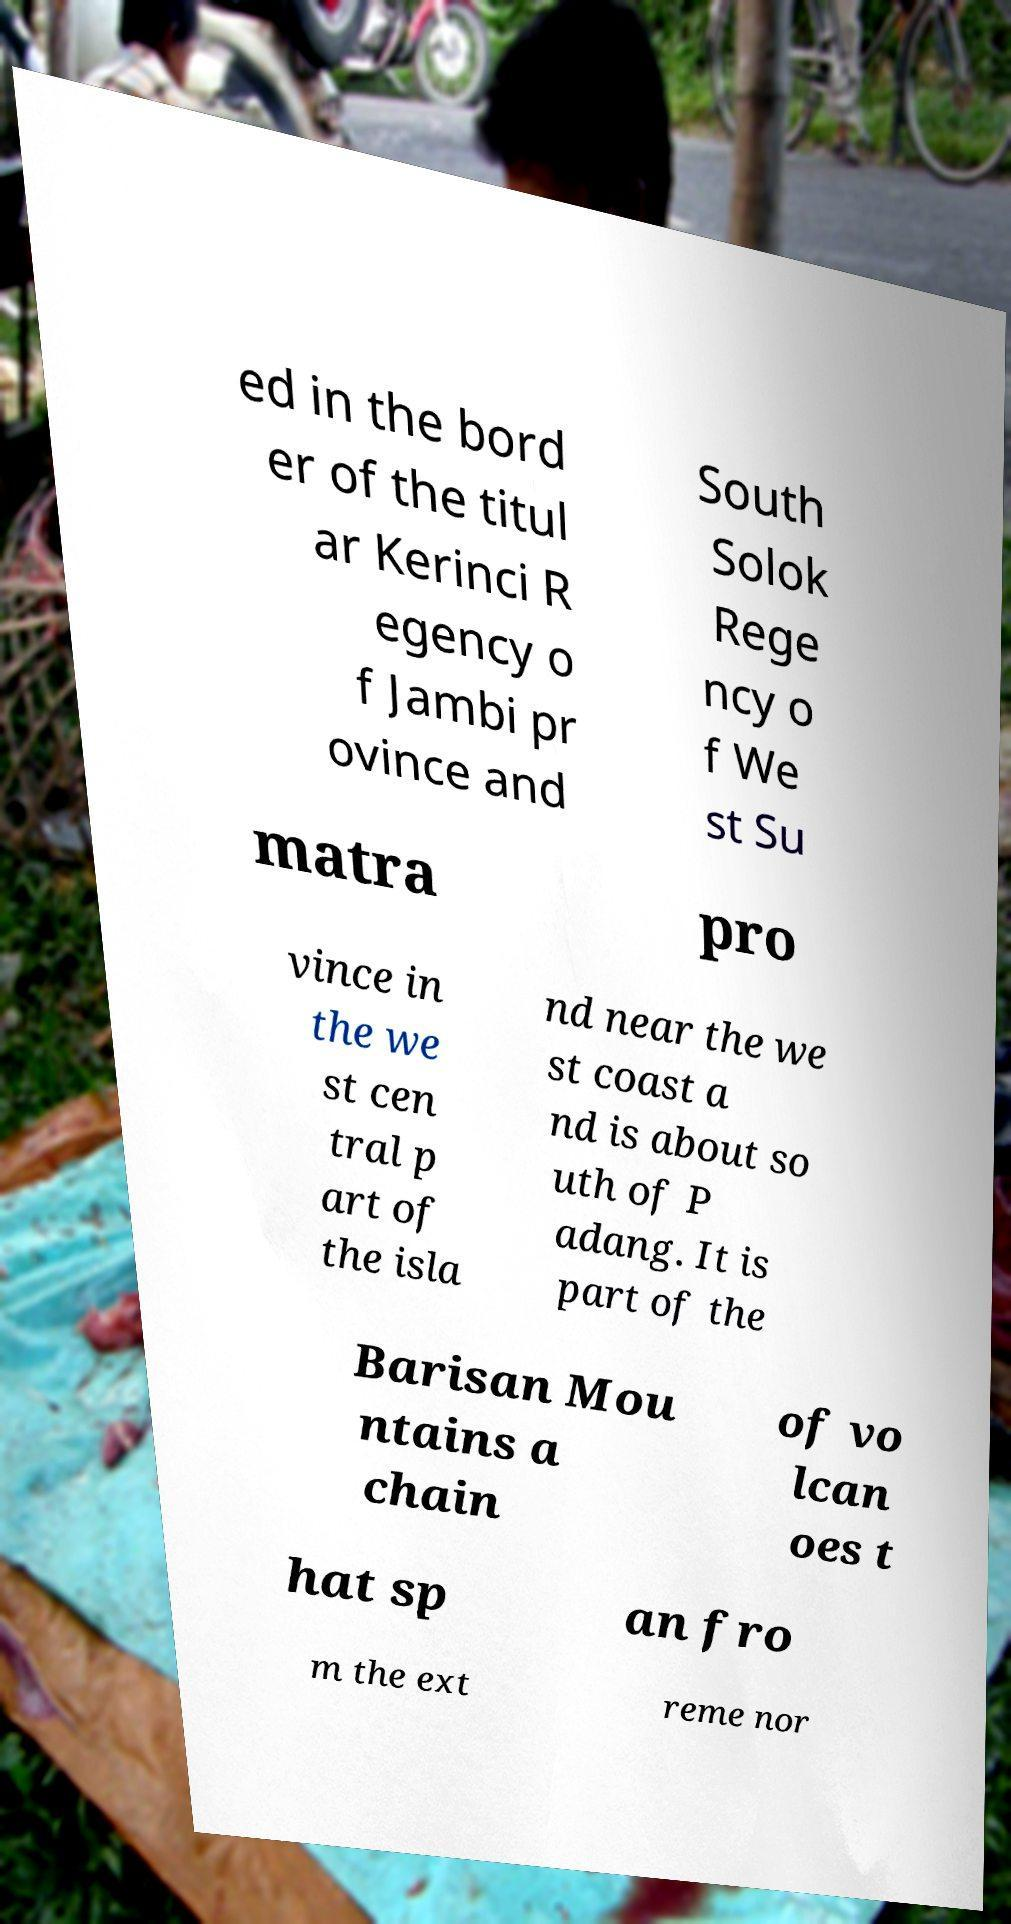Please identify and transcribe the text found in this image. ed in the bord er of the titul ar Kerinci R egency o f Jambi pr ovince and South Solok Rege ncy o f We st Su matra pro vince in the we st cen tral p art of the isla nd near the we st coast a nd is about so uth of P adang. It is part of the Barisan Mou ntains a chain of vo lcan oes t hat sp an fro m the ext reme nor 